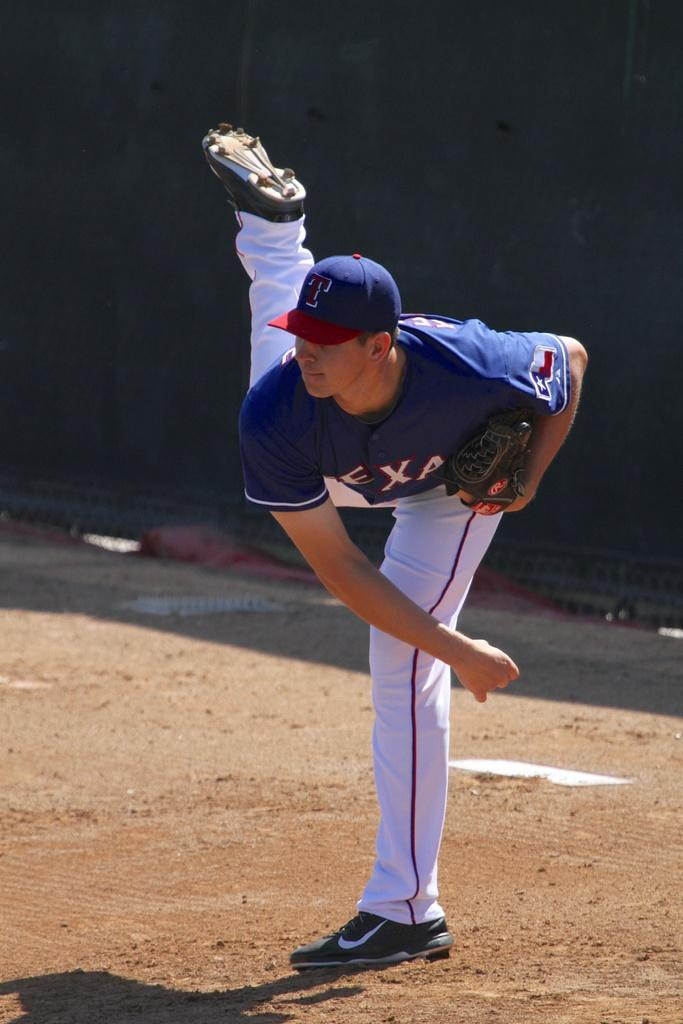<image>
Relay a brief, clear account of the picture shown. A baseball player wearing a cap with a T on it 